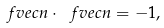<formula> <loc_0><loc_0><loc_500><loc_500>\ f v e c { n } \cdot \ f v e c { n } = - 1 ,</formula> 